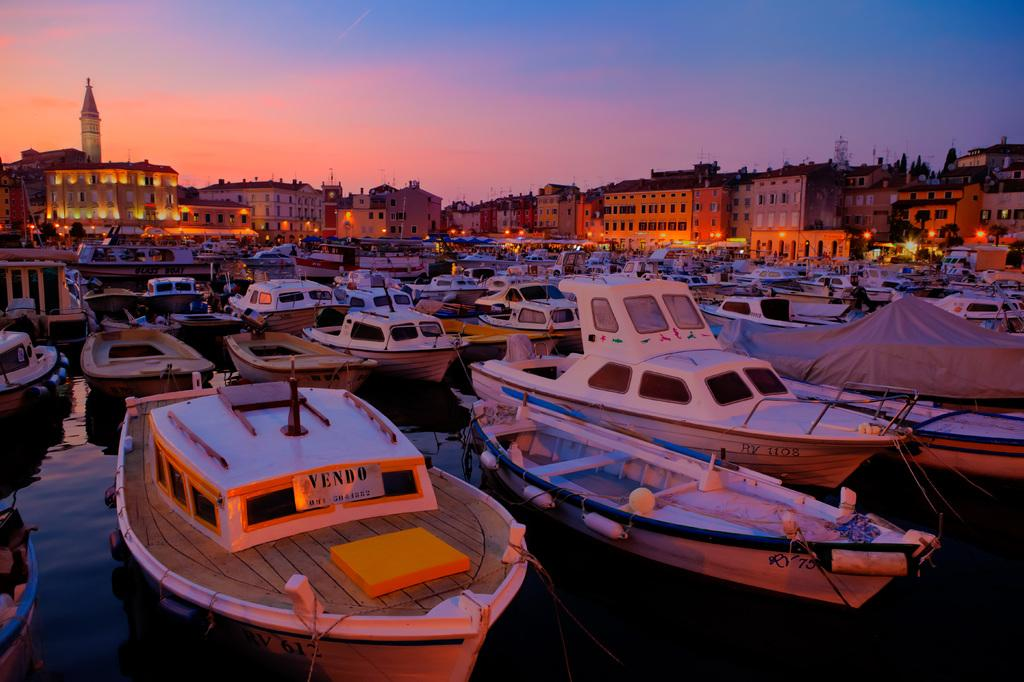What is in the water in the image? There are ships in the water in the image. What can be seen in the background of the image? There are buildings and towers in the background, as well as the sky. How many pans can be seen falling from the towers in the image? There are no pans visible in the image, nor are any falling from the towers. 